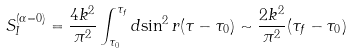Convert formula to latex. <formula><loc_0><loc_0><loc_500><loc_500>S _ { I } ^ { ( \alpha = 0 ) } = \frac { 4 k ^ { 2 } } { \pi ^ { 2 } } \int _ { \tau _ { 0 } } ^ { \tau _ { f } } d { \sin } ^ { 2 } \, r ( \tau - \tau _ { 0 } ) \sim \frac { 2 k ^ { 2 } } { \pi ^ { 2 } } ( \tau _ { f } - \tau _ { 0 } )</formula> 